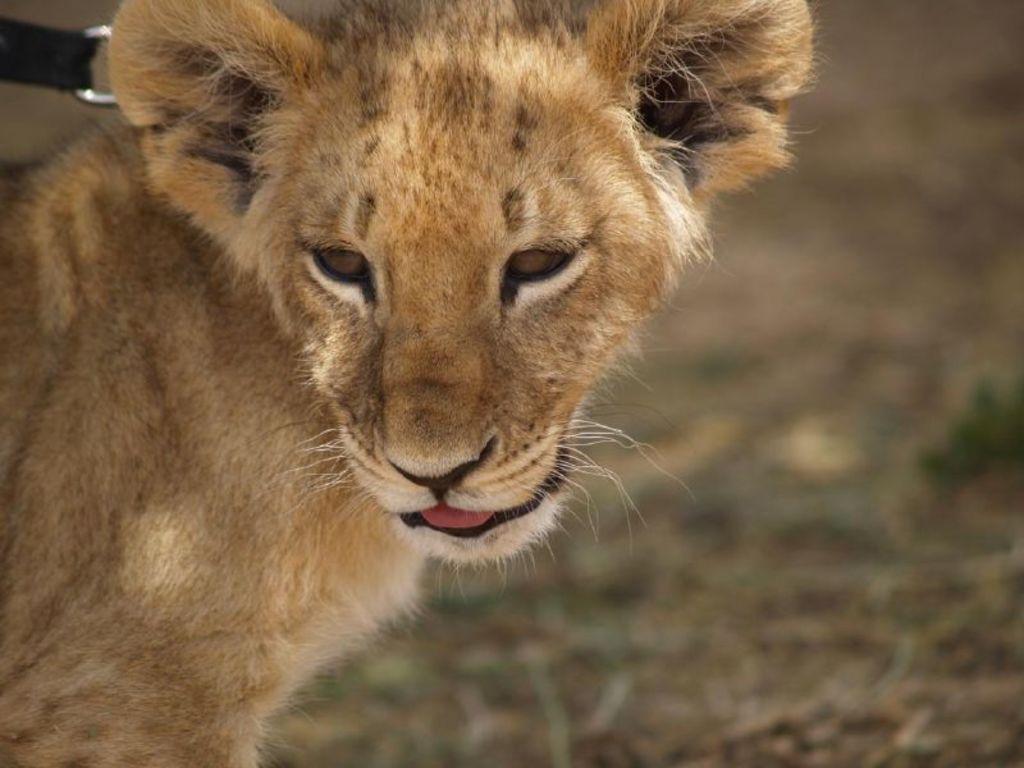Could you give a brief overview of what you see in this image? In this image I can see a animal which is in brown,white and black color. Background is blurred. 